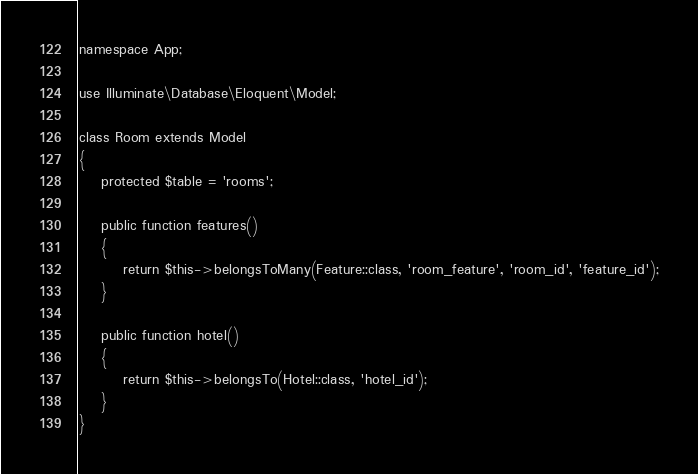Convert code to text. <code><loc_0><loc_0><loc_500><loc_500><_PHP_>namespace App;

use Illuminate\Database\Eloquent\Model;

class Room extends Model
{
    protected $table = 'rooms';

    public function features()
    {
        return $this->belongsToMany(Feature::class, 'room_feature', 'room_id', 'feature_id');
    }

    public function hotel()
    {
        return $this->belongsTo(Hotel::class, 'hotel_id');
    }
}
</code> 